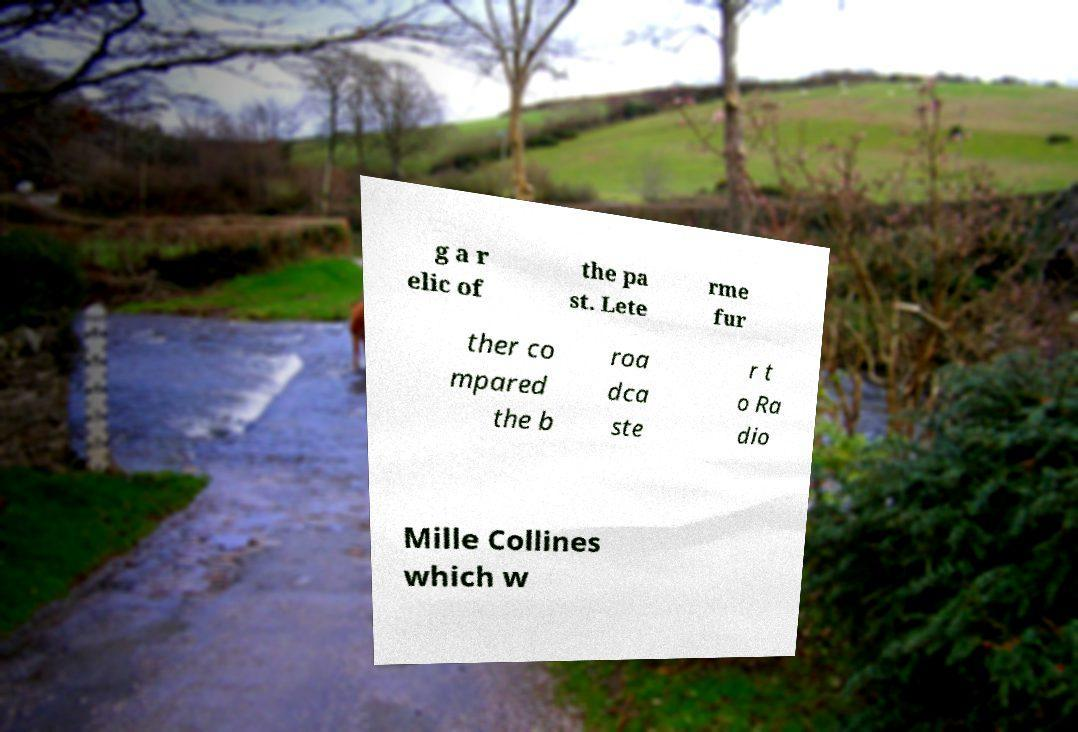Can you read and provide the text displayed in the image?This photo seems to have some interesting text. Can you extract and type it out for me? g a r elic of the pa st. Lete rme fur ther co mpared the b roa dca ste r t o Ra dio Mille Collines which w 